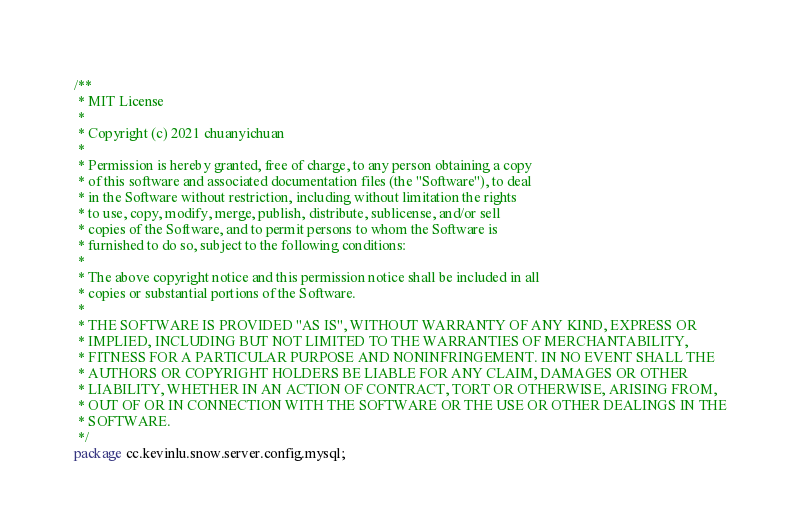<code> <loc_0><loc_0><loc_500><loc_500><_Java_>/**
 * MIT License
 *
 * Copyright (c) 2021 chuanyichuan
 *
 * Permission is hereby granted, free of charge, to any person obtaining a copy
 * of this software and associated documentation files (the "Software"), to deal
 * in the Software without restriction, including without limitation the rights
 * to use, copy, modify, merge, publish, distribute, sublicense, and/or sell
 * copies of the Software, and to permit persons to whom the Software is
 * furnished to do so, subject to the following conditions:
 *
 * The above copyright notice and this permission notice shall be included in all
 * copies or substantial portions of the Software.
 *
 * THE SOFTWARE IS PROVIDED "AS IS", WITHOUT WARRANTY OF ANY KIND, EXPRESS OR
 * IMPLIED, INCLUDING BUT NOT LIMITED TO THE WARRANTIES OF MERCHANTABILITY,
 * FITNESS FOR A PARTICULAR PURPOSE AND NONINFRINGEMENT. IN NO EVENT SHALL THE
 * AUTHORS OR COPYRIGHT HOLDERS BE LIABLE FOR ANY CLAIM, DAMAGES OR OTHER
 * LIABILITY, WHETHER IN AN ACTION OF CONTRACT, TORT OR OTHERWISE, ARISING FROM,
 * OUT OF OR IN CONNECTION WITH THE SOFTWARE OR THE USE OR OTHER DEALINGS IN THE
 * SOFTWARE.
 */
package cc.kevinlu.snow.server.config.mysql;
</code> 